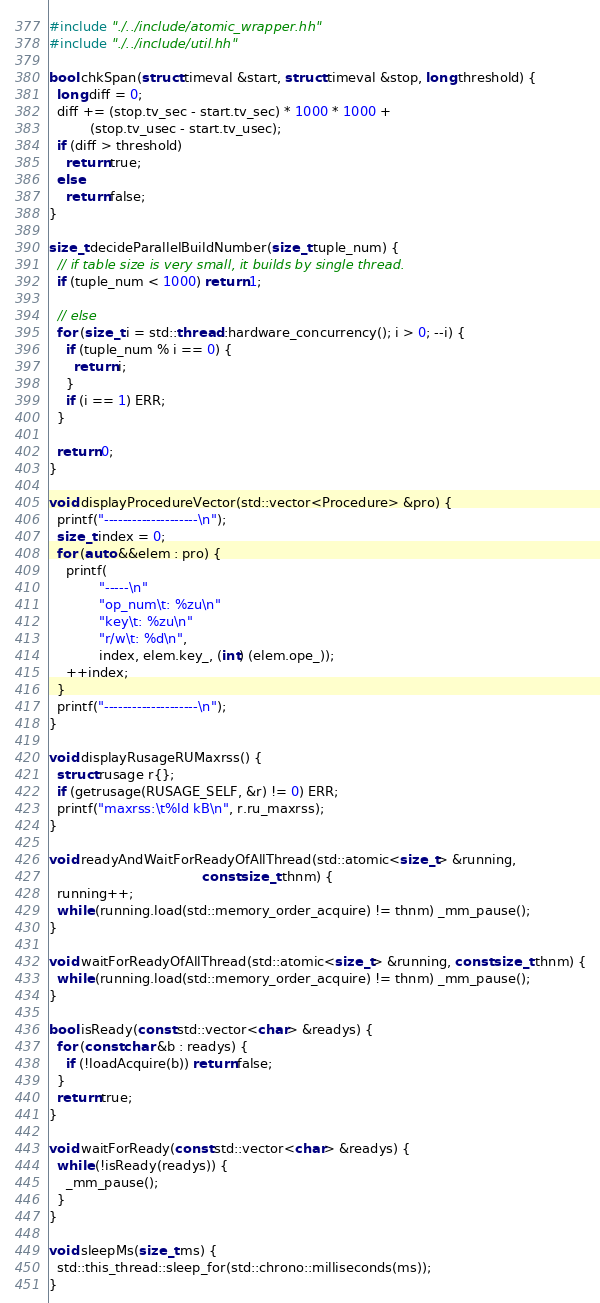<code> <loc_0><loc_0><loc_500><loc_500><_C++_>
#include "./../include/atomic_wrapper.hh"
#include "./../include/util.hh"

bool chkSpan(struct timeval &start, struct timeval &stop, long threshold) {
  long diff = 0;
  diff += (stop.tv_sec - start.tv_sec) * 1000 * 1000 +
          (stop.tv_usec - start.tv_usec);
  if (diff > threshold)
    return true;
  else
    return false;
}

size_t decideParallelBuildNumber(size_t tuple_num) {
  // if table size is very small, it builds by single thread.
  if (tuple_num < 1000) return 1;

  // else
  for (size_t i = std::thread::hardware_concurrency(); i > 0; --i) {
    if (tuple_num % i == 0) {
      return i;
    }
    if (i == 1) ERR;
  }

  return 0;
}

void displayProcedureVector(std::vector<Procedure> &pro) {
  printf("--------------------\n");
  size_t index = 0;
  for (auto &&elem : pro) {
    printf(
            "-----\n"
            "op_num\t: %zu\n"
            "key\t: %zu\n"
            "r/w\t: %d\n",
            index, elem.key_, (int) (elem.ope_));
    ++index;
  }
  printf("--------------------\n");
}

void displayRusageRUMaxrss() {
  struct rusage r{};
  if (getrusage(RUSAGE_SELF, &r) != 0) ERR;
  printf("maxrss:\t%ld kB\n", r.ru_maxrss);
}

void readyAndWaitForReadyOfAllThread(std::atomic<size_t> &running,
                                     const size_t thnm) {
  running++;
  while (running.load(std::memory_order_acquire) != thnm) _mm_pause();
}

void waitForReadyOfAllThread(std::atomic<size_t> &running, const size_t thnm) {
  while (running.load(std::memory_order_acquire) != thnm) _mm_pause();
}

bool isReady(const std::vector<char> &readys) {
  for (const char &b : readys) {
    if (!loadAcquire(b)) return false;
  }
  return true;
}

void waitForReady(const std::vector<char> &readys) {
  while (!isReady(readys)) {
    _mm_pause();
  }
}

void sleepMs(size_t ms) {
  std::this_thread::sleep_for(std::chrono::milliseconds(ms));
}
</code> 